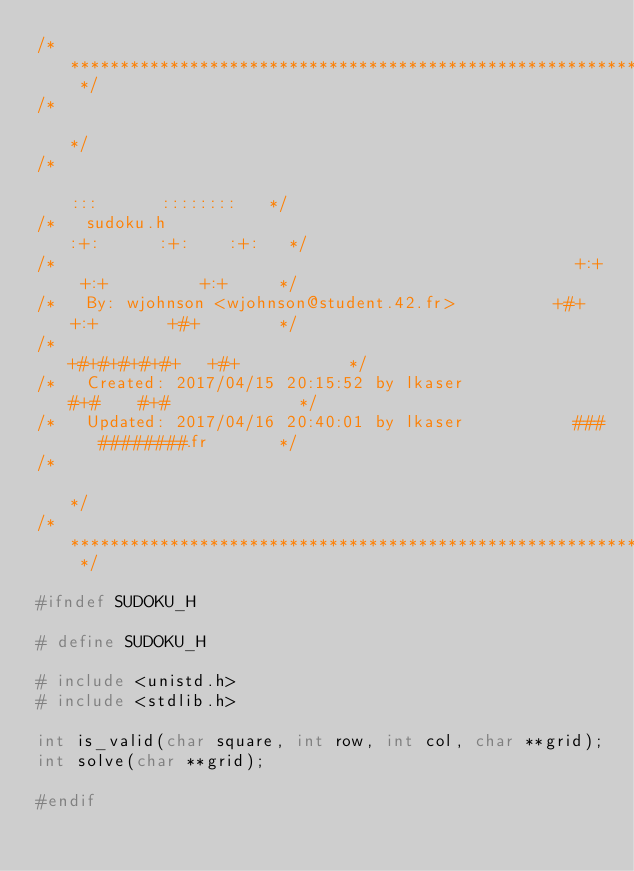Convert code to text. <code><loc_0><loc_0><loc_500><loc_500><_C_>/* ************************************************************************** */
/*                                                                            */
/*                                                        :::      ::::::::   */
/*   sudoku.h                                           :+:      :+:    :+:   */
/*                                                    +:+ +:+         +:+     */
/*   By: wjohnson <wjohnson@student.42.fr>          +#+  +:+       +#+        */
/*                                                +#+#+#+#+#+   +#+           */
/*   Created: 2017/04/15 20:15:52 by lkaser            #+#    #+#             */
/*   Updated: 2017/04/16 20:40:01 by lkaser           ###   ########.fr       */
/*                                                                            */
/* ************************************************************************** */

#ifndef SUDOKU_H

# define SUDOKU_H

# include <unistd.h>
# include <stdlib.h>

int	is_valid(char square, int row, int col, char **grid);
int	solve(char **grid);

#endif
</code> 